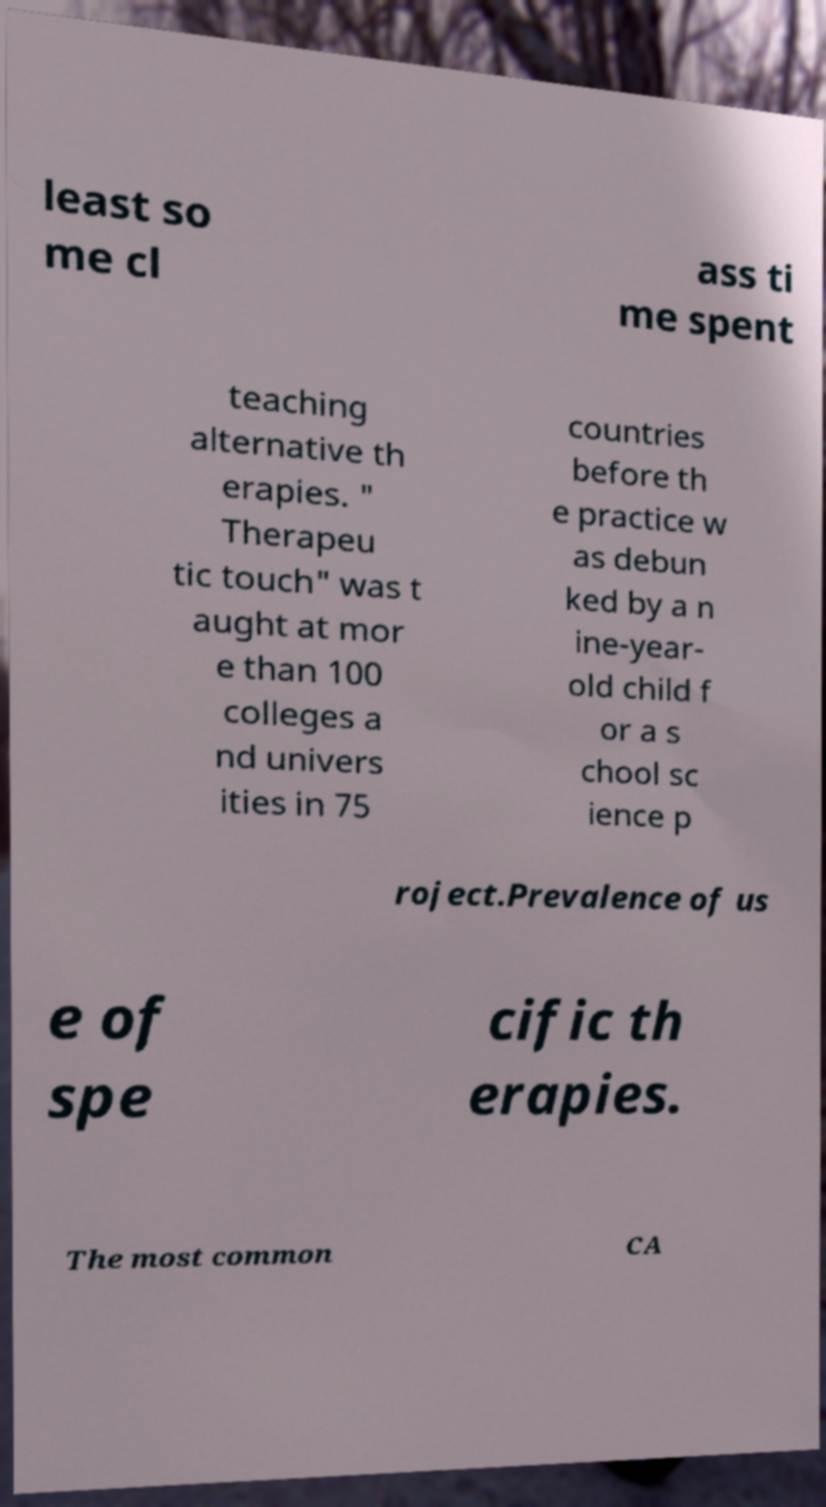Please identify and transcribe the text found in this image. least so me cl ass ti me spent teaching alternative th erapies. " Therapeu tic touch" was t aught at mor e than 100 colleges a nd univers ities in 75 countries before th e practice w as debun ked by a n ine-year- old child f or a s chool sc ience p roject.Prevalence of us e of spe cific th erapies. The most common CA 